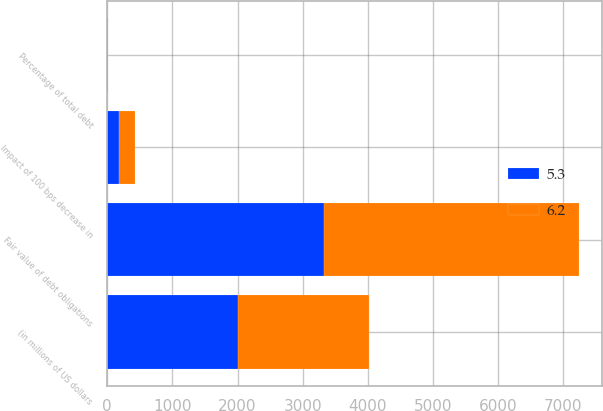<chart> <loc_0><loc_0><loc_500><loc_500><stacked_bar_chart><ecel><fcel>(in millions of US dollars<fcel>Fair value of debt obligations<fcel>Impact of 100 bps decrease in<fcel>Percentage of total debt<nl><fcel>6.2<fcel>2009<fcel>3905<fcel>241<fcel>6.2<nl><fcel>5.3<fcel>2008<fcel>3334<fcel>179<fcel>5.3<nl></chart> 